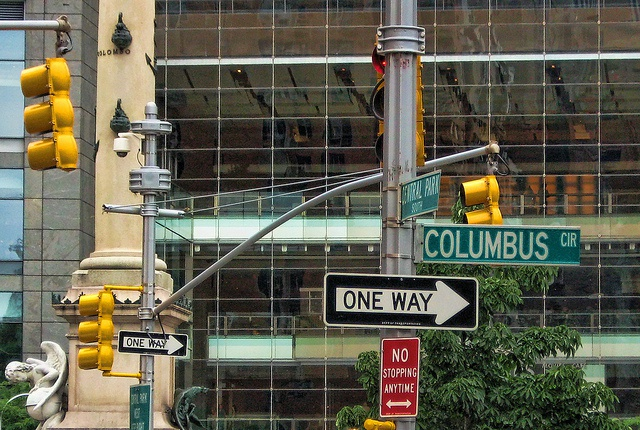Describe the objects in this image and their specific colors. I can see traffic light in teal, orange, olive, and gold tones, traffic light in teal, olive, orange, and gold tones, traffic light in teal, black, olive, and maroon tones, and traffic light in teal, orange, olive, and gold tones in this image. 